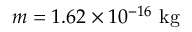<formula> <loc_0><loc_0><loc_500><loc_500>m = 1 . 6 2 \times 1 0 ^ { - 1 6 } k g</formula> 